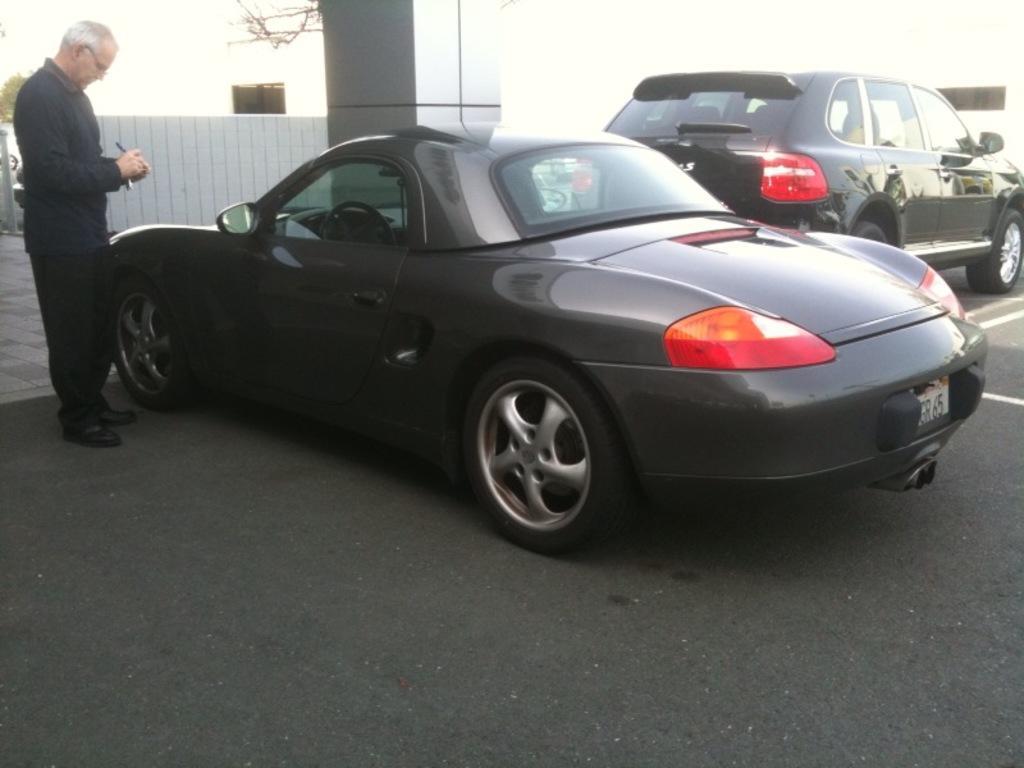How would you summarize this image in a sentence or two? In this picture I can see 2 black color cars on the road and on the left side of this picture I can see a man who is wearing black dress. In the background I can see the fencing and I can also see white color background. 